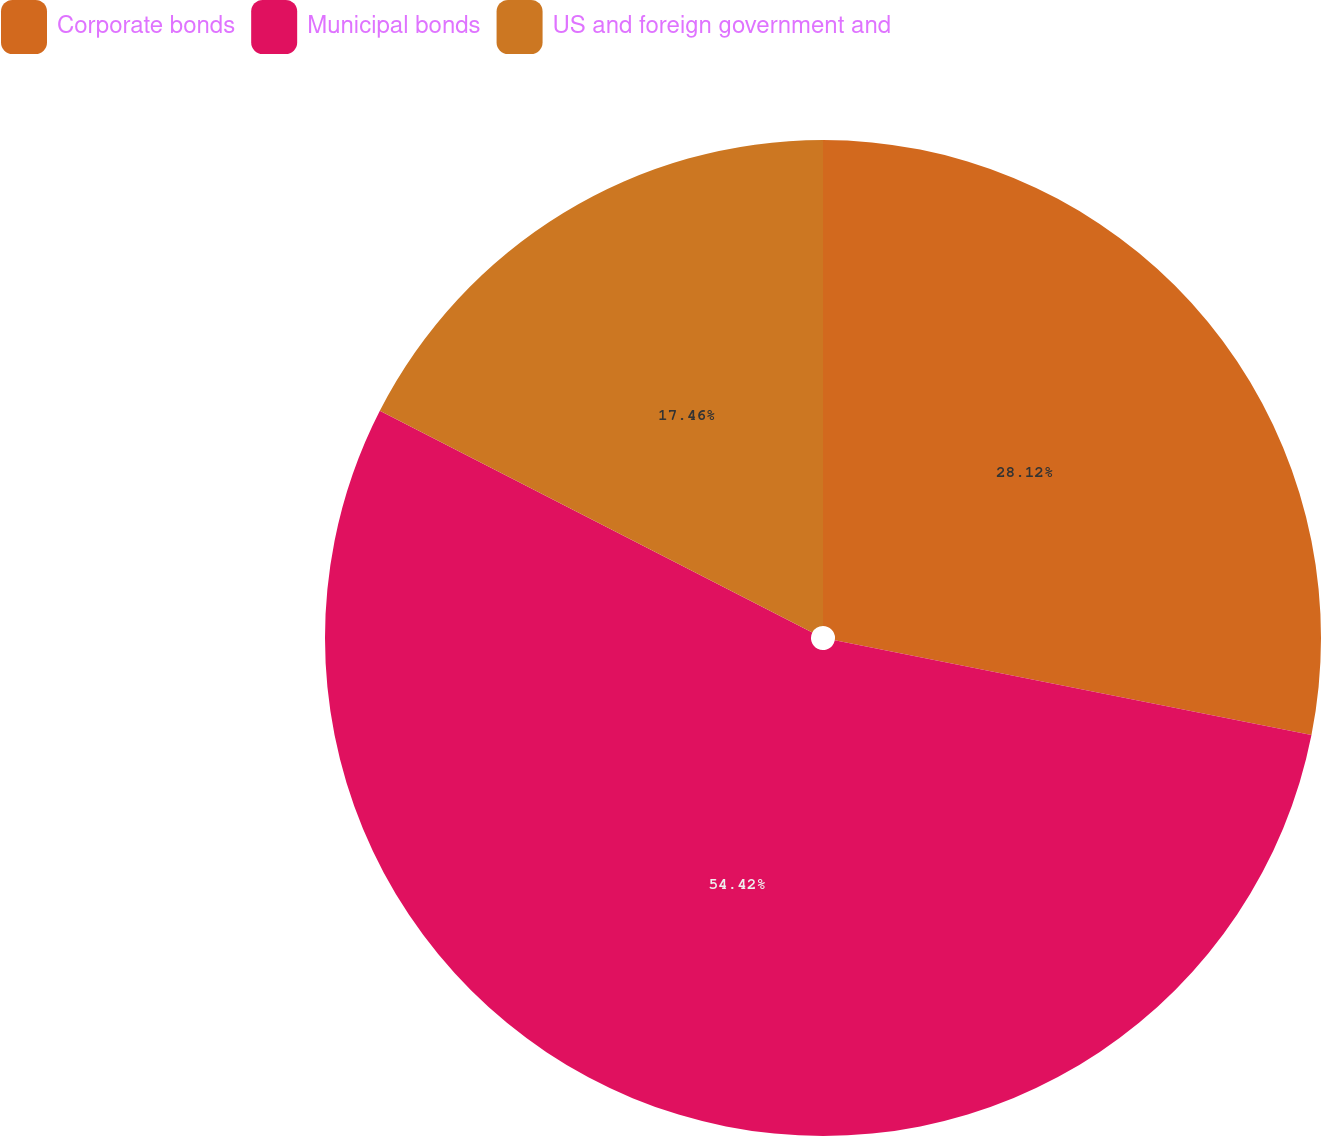Convert chart to OTSL. <chart><loc_0><loc_0><loc_500><loc_500><pie_chart><fcel>Corporate bonds<fcel>Municipal bonds<fcel>US and foreign government and<nl><fcel>28.12%<fcel>54.42%<fcel>17.46%<nl></chart> 